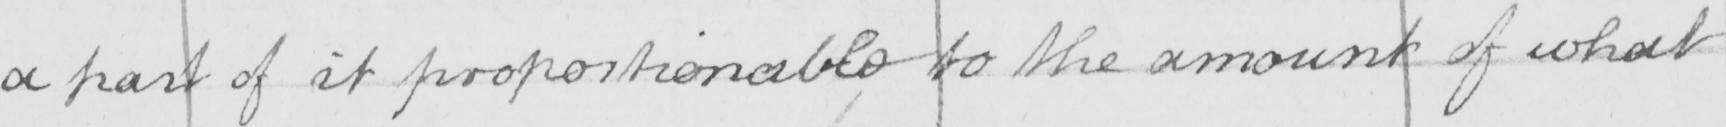What text is written in this handwritten line? a part of it proportionable to the amount of what 